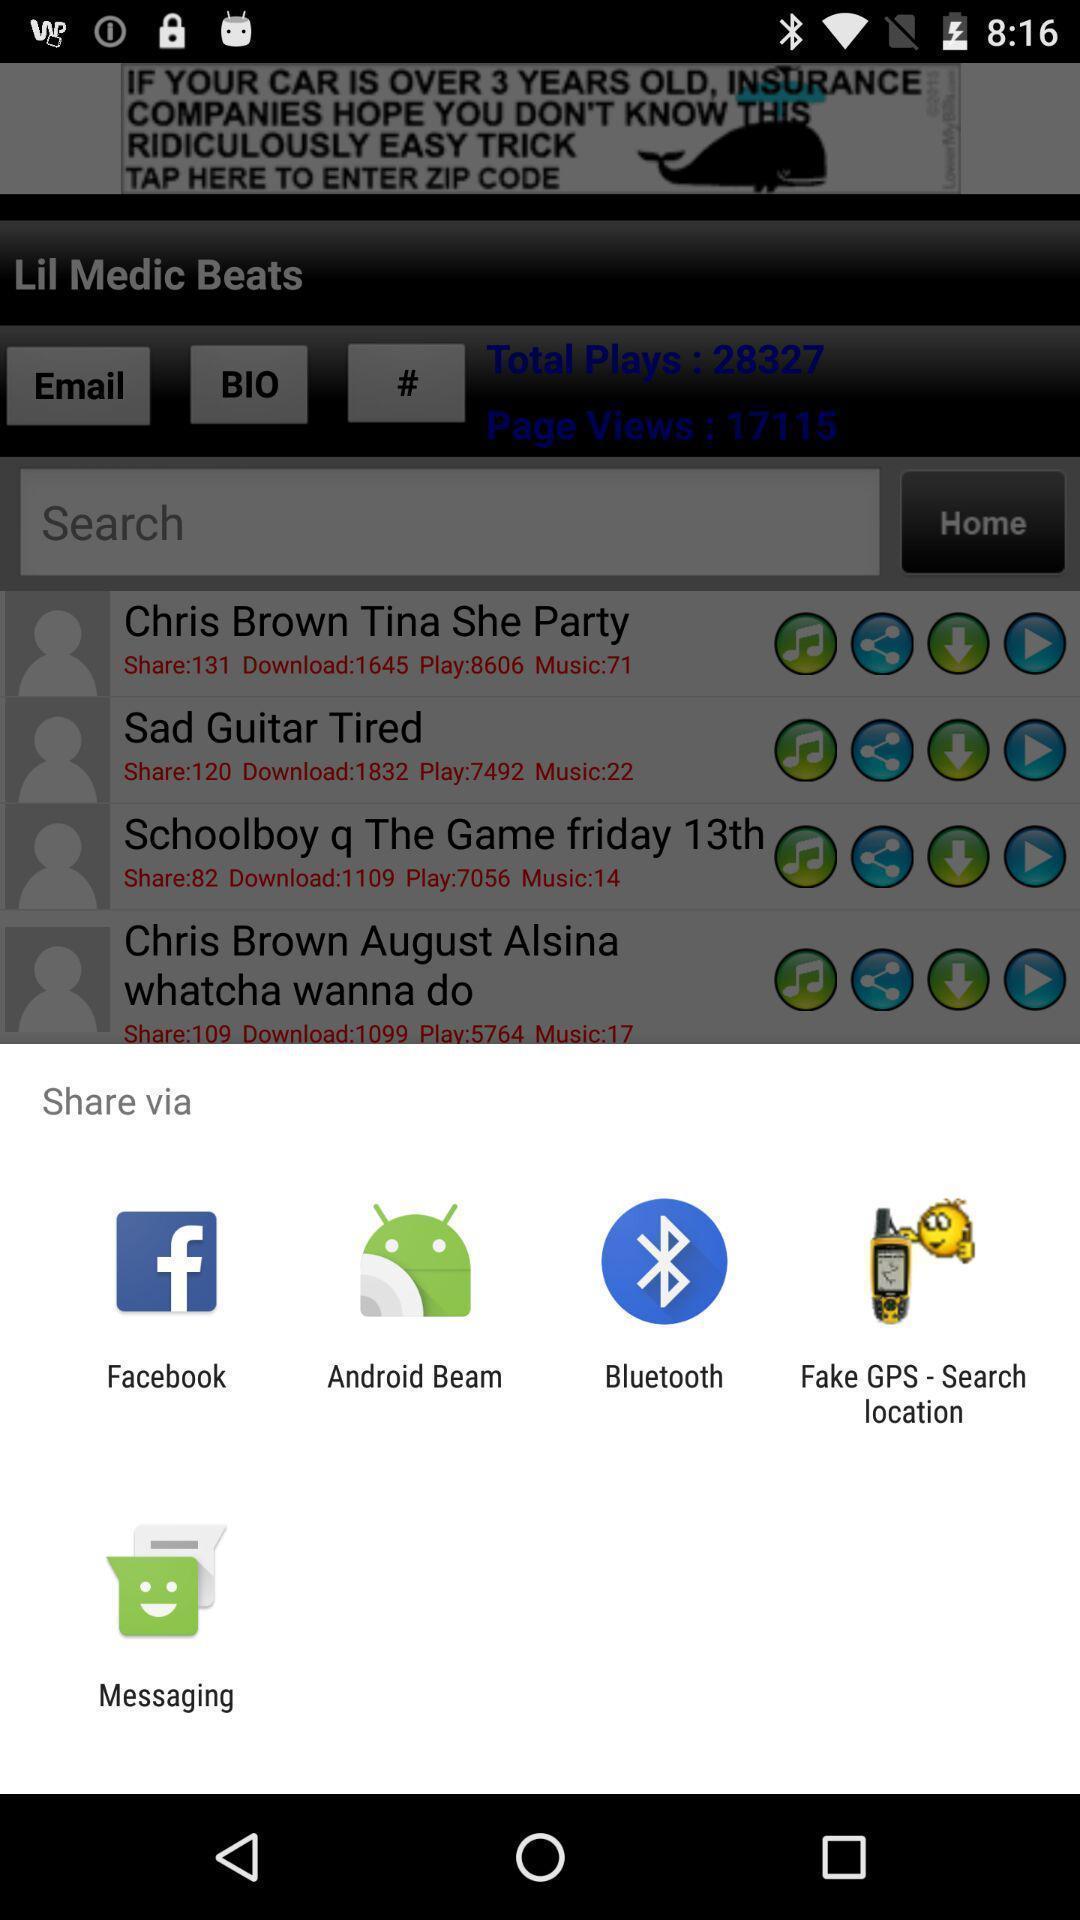Give me a summary of this screen capture. Pop-up showing different apps to share the albums. 